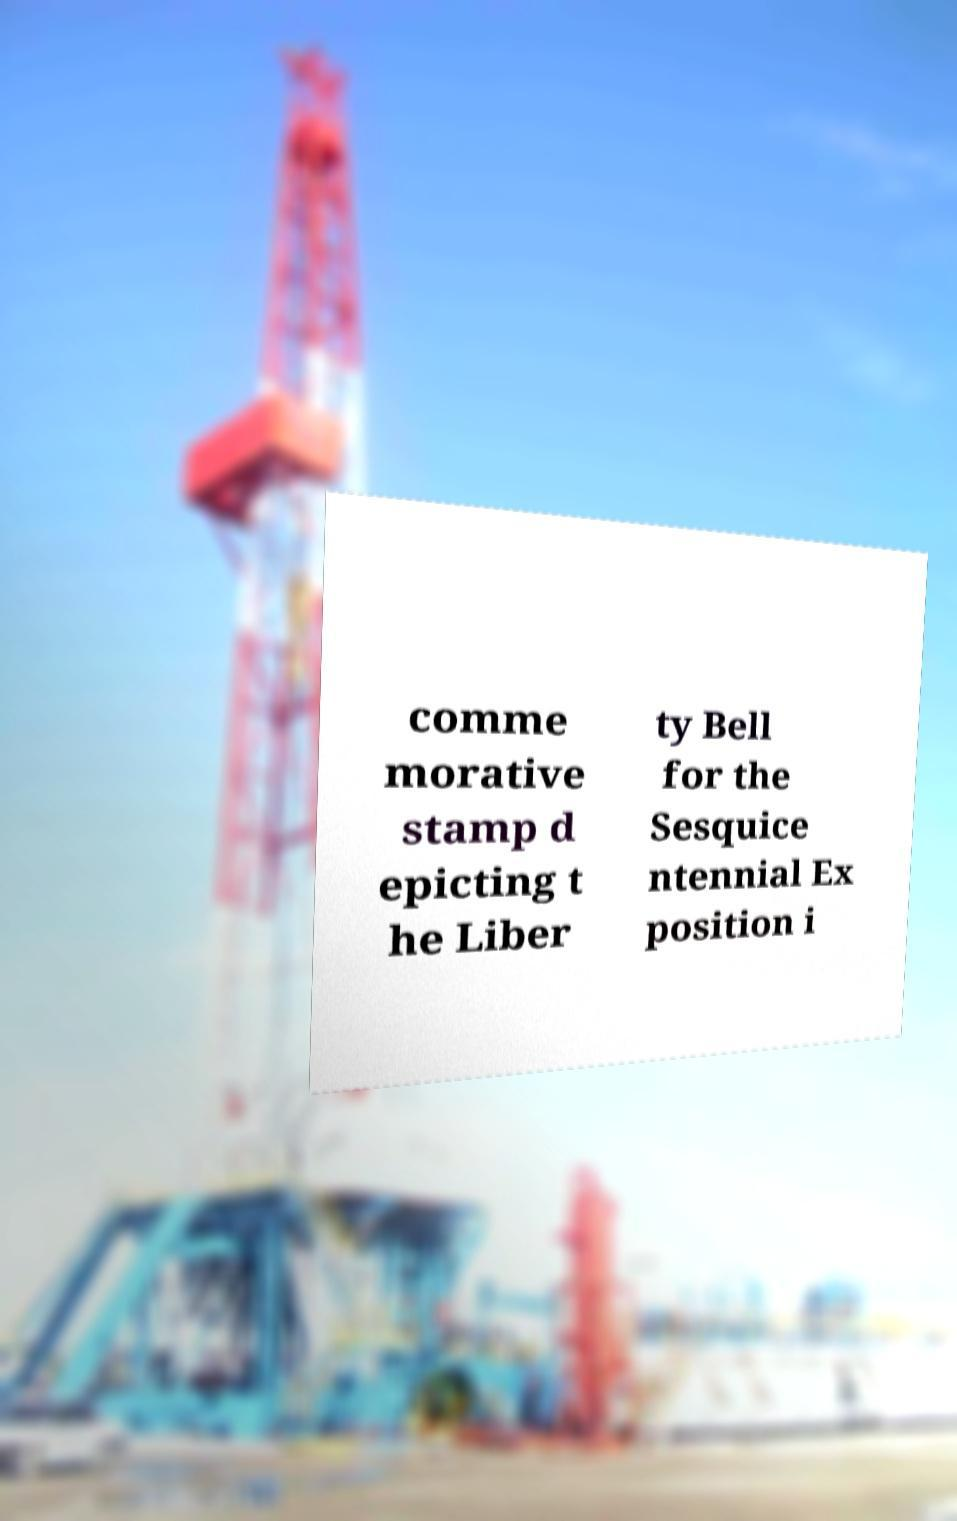I need the written content from this picture converted into text. Can you do that? comme morative stamp d epicting t he Liber ty Bell for the Sesquice ntennial Ex position i 